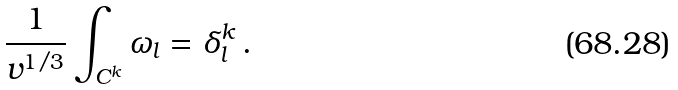<formula> <loc_0><loc_0><loc_500><loc_500>\frac { 1 } { v ^ { 1 / 3 } } \int _ { C ^ { k } } \omega _ { l } = \delta _ { l } ^ { k } \, .</formula> 